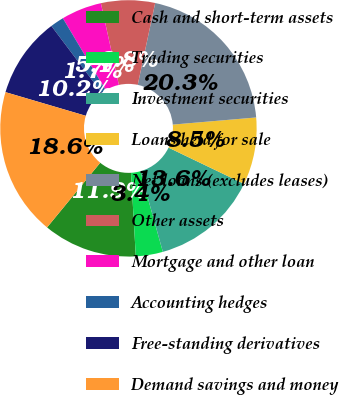Convert chart. <chart><loc_0><loc_0><loc_500><loc_500><pie_chart><fcel>Cash and short-term assets<fcel>Trading securities<fcel>Investment securities<fcel>Loans held for sale<fcel>Net loans (excludes leases)<fcel>Other assets<fcel>Mortgage and other loan<fcel>Accounting hedges<fcel>Free-standing derivatives<fcel>Demand savings and money<nl><fcel>11.86%<fcel>3.41%<fcel>13.55%<fcel>8.48%<fcel>20.3%<fcel>6.79%<fcel>5.1%<fcel>1.72%<fcel>10.17%<fcel>18.61%<nl></chart> 